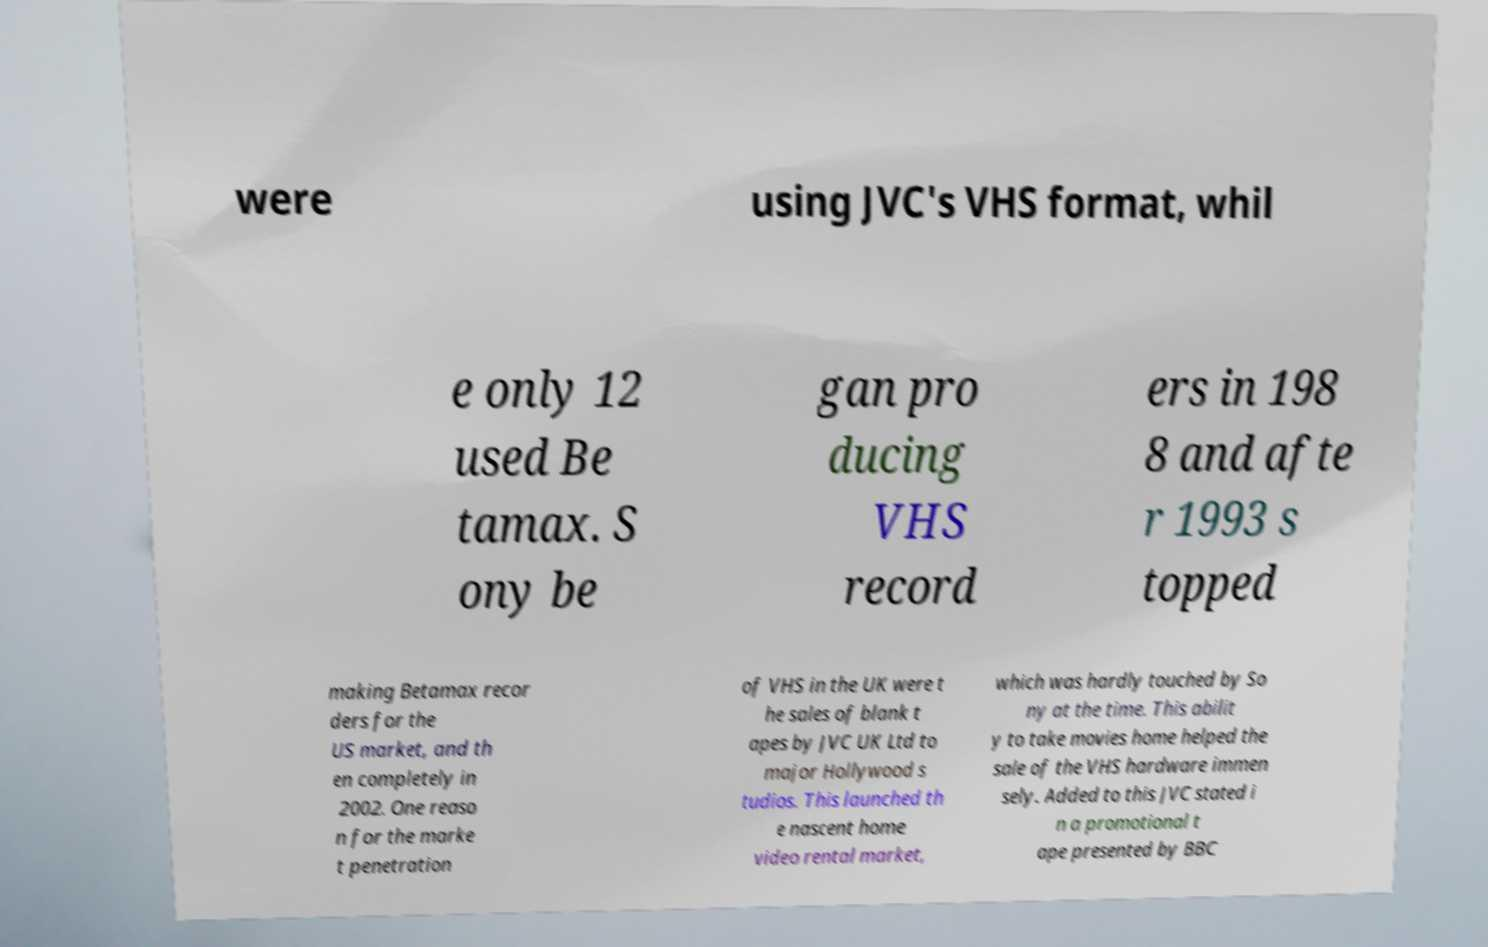I need the written content from this picture converted into text. Can you do that? were using JVC's VHS format, whil e only 12 used Be tamax. S ony be gan pro ducing VHS record ers in 198 8 and afte r 1993 s topped making Betamax recor ders for the US market, and th en completely in 2002. One reaso n for the marke t penetration of VHS in the UK were t he sales of blank t apes by JVC UK Ltd to major Hollywood s tudios. This launched th e nascent home video rental market, which was hardly touched by So ny at the time. This abilit y to take movies home helped the sale of the VHS hardware immen sely. Added to this JVC stated i n a promotional t ape presented by BBC 